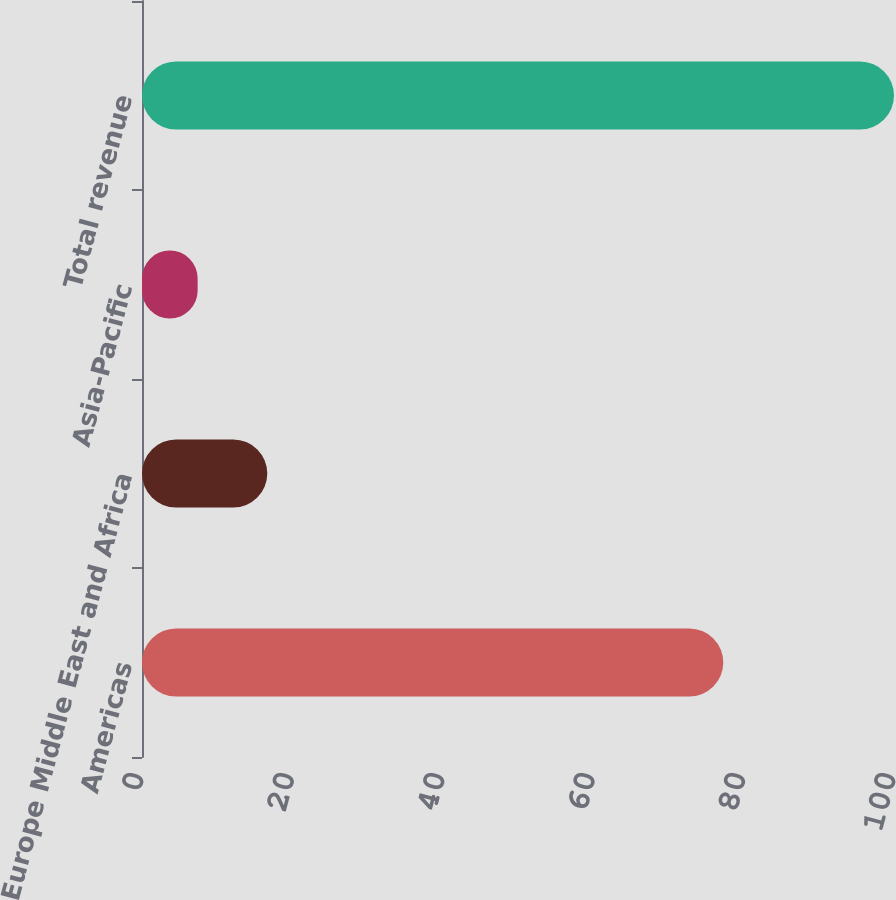<chart> <loc_0><loc_0><loc_500><loc_500><bar_chart><fcel>Americas<fcel>Europe Middle East and Africa<fcel>Asia-Pacific<fcel>Total revenue<nl><fcel>77.3<fcel>16.66<fcel>7.4<fcel>100<nl></chart> 